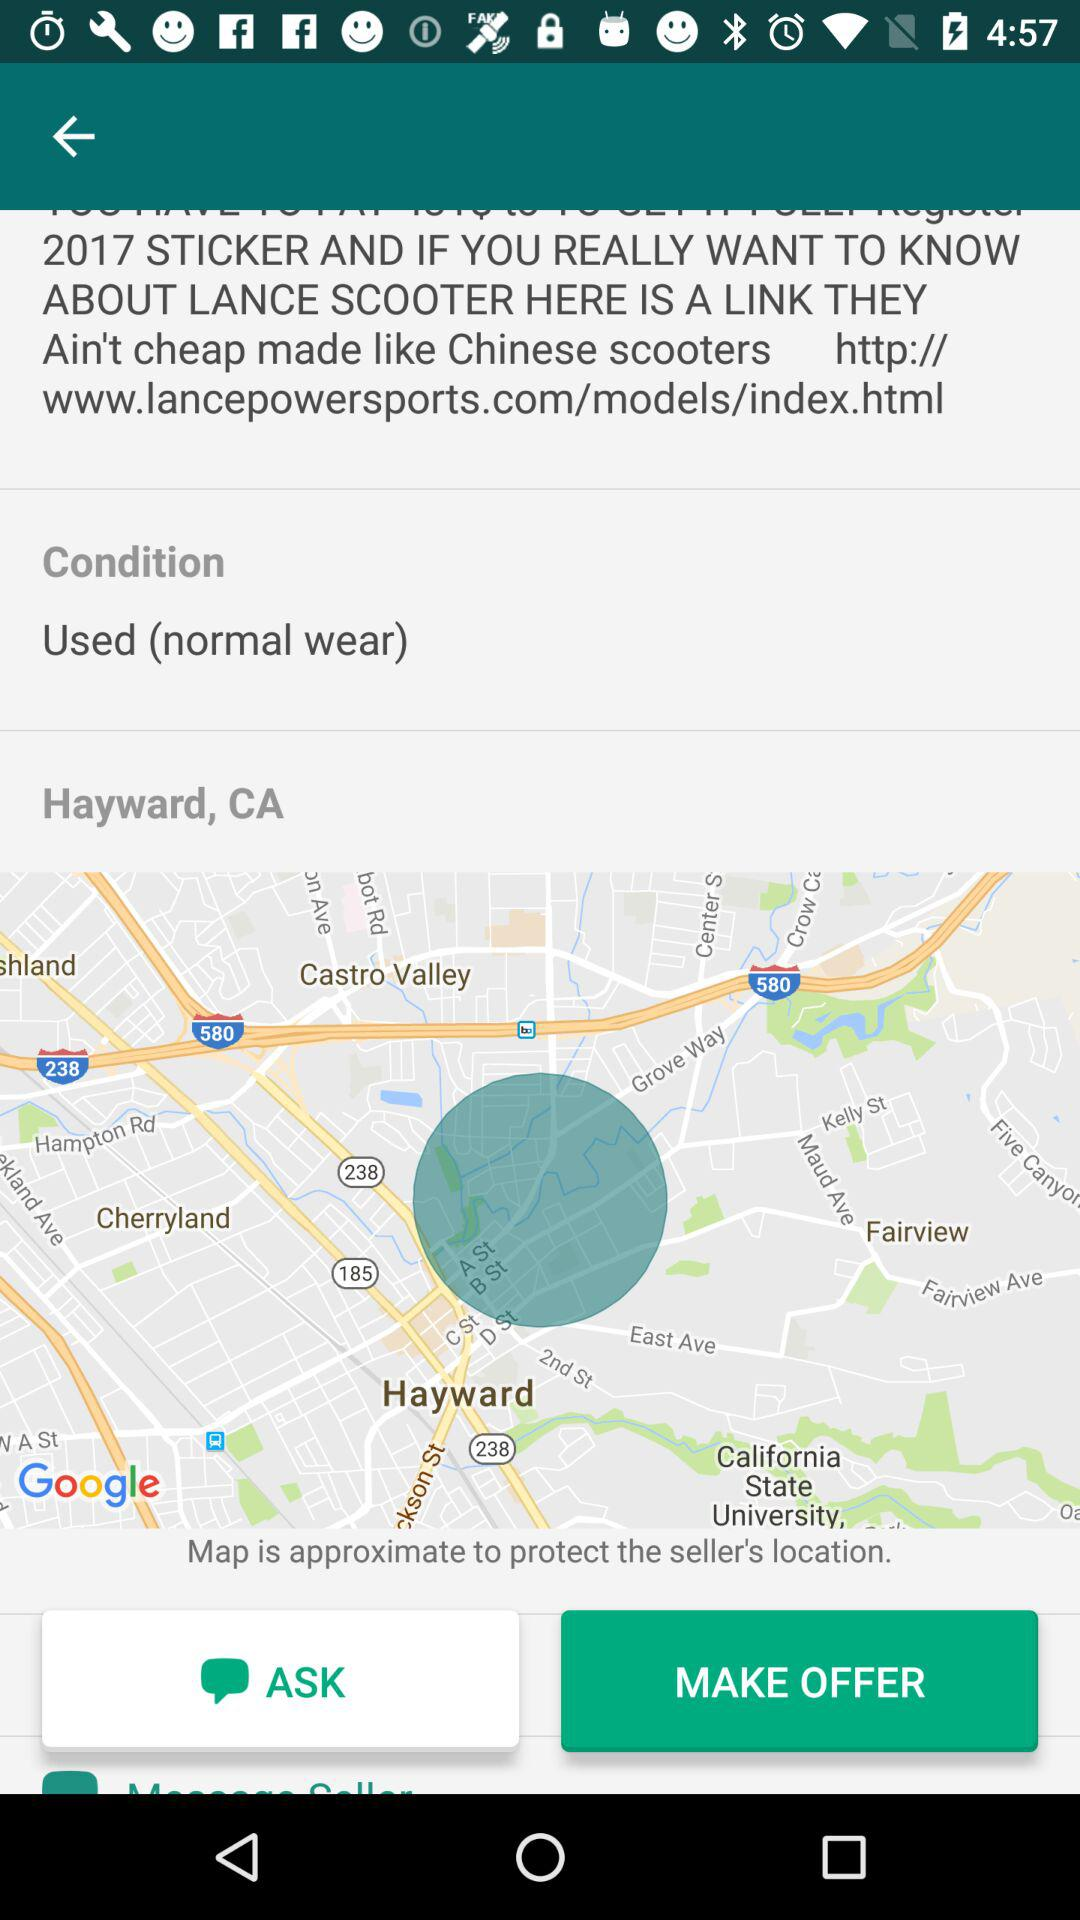Who is making an offer?
When the provided information is insufficient, respond with <no answer>. <no answer> 